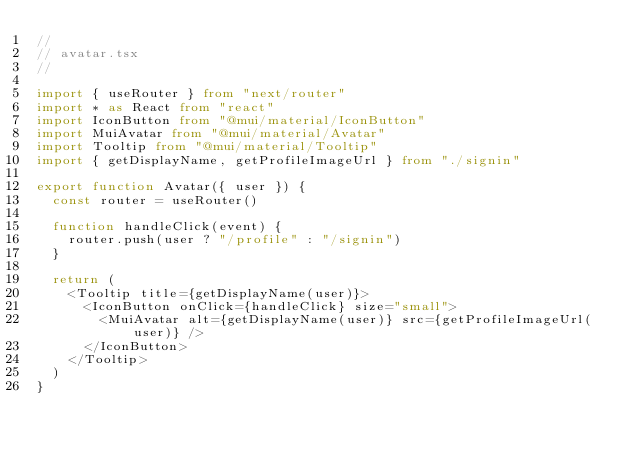Convert code to text. <code><loc_0><loc_0><loc_500><loc_500><_TypeScript_>//
// avatar.tsx
//

import { useRouter } from "next/router"
import * as React from "react"
import IconButton from "@mui/material/IconButton"
import MuiAvatar from "@mui/material/Avatar"
import Tooltip from "@mui/material/Tooltip"
import { getDisplayName, getProfileImageUrl } from "./signin"

export function Avatar({ user }) {
  const router = useRouter()

  function handleClick(event) {
    router.push(user ? "/profile" : "/signin")
  }

  return (
    <Tooltip title={getDisplayName(user)}>
      <IconButton onClick={handleClick} size="small">
        <MuiAvatar alt={getDisplayName(user)} src={getProfileImageUrl(user)} />
      </IconButton>
    </Tooltip>
  )
}
</code> 